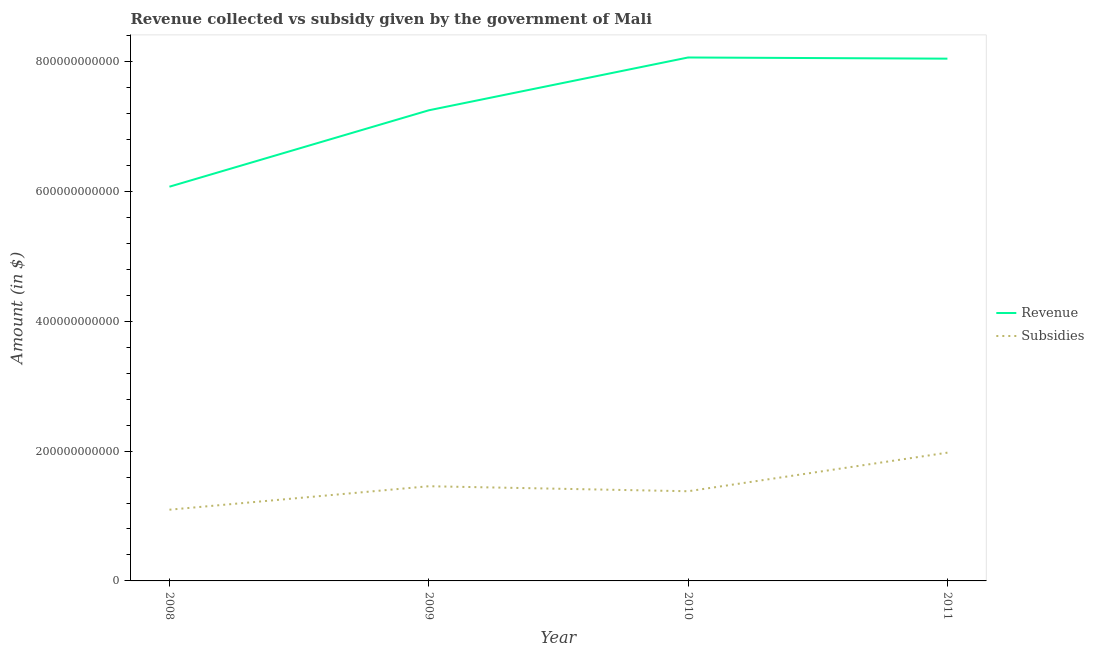How many different coloured lines are there?
Your answer should be compact. 2. Is the number of lines equal to the number of legend labels?
Make the answer very short. Yes. What is the amount of subsidies given in 2010?
Give a very brief answer. 1.38e+11. Across all years, what is the maximum amount of subsidies given?
Make the answer very short. 1.98e+11. Across all years, what is the minimum amount of subsidies given?
Provide a short and direct response. 1.10e+11. In which year was the amount of subsidies given maximum?
Your response must be concise. 2011. In which year was the amount of revenue collected minimum?
Make the answer very short. 2008. What is the total amount of revenue collected in the graph?
Offer a very short reply. 2.94e+12. What is the difference between the amount of subsidies given in 2008 and that in 2009?
Give a very brief answer. -3.62e+1. What is the difference between the amount of subsidies given in 2009 and the amount of revenue collected in 2008?
Ensure brevity in your answer.  -4.61e+11. What is the average amount of subsidies given per year?
Provide a succinct answer. 1.48e+11. In the year 2009, what is the difference between the amount of subsidies given and amount of revenue collected?
Keep it short and to the point. -5.79e+11. In how many years, is the amount of revenue collected greater than 240000000000 $?
Your answer should be very brief. 4. What is the ratio of the amount of subsidies given in 2008 to that in 2011?
Offer a terse response. 0.56. Is the amount of subsidies given in 2009 less than that in 2011?
Provide a short and direct response. Yes. What is the difference between the highest and the second highest amount of subsidies given?
Make the answer very short. 5.17e+1. What is the difference between the highest and the lowest amount of revenue collected?
Provide a succinct answer. 1.99e+11. In how many years, is the amount of revenue collected greater than the average amount of revenue collected taken over all years?
Offer a terse response. 2. Does the amount of subsidies given monotonically increase over the years?
Ensure brevity in your answer.  No. Is the amount of subsidies given strictly less than the amount of revenue collected over the years?
Your answer should be very brief. Yes. How many lines are there?
Make the answer very short. 2. How many years are there in the graph?
Your response must be concise. 4. What is the difference between two consecutive major ticks on the Y-axis?
Provide a short and direct response. 2.00e+11. How many legend labels are there?
Give a very brief answer. 2. What is the title of the graph?
Provide a short and direct response. Revenue collected vs subsidy given by the government of Mali. What is the label or title of the Y-axis?
Offer a very short reply. Amount (in $). What is the Amount (in $) in Revenue in 2008?
Provide a succinct answer. 6.07e+11. What is the Amount (in $) in Subsidies in 2008?
Provide a succinct answer. 1.10e+11. What is the Amount (in $) in Revenue in 2009?
Make the answer very short. 7.25e+11. What is the Amount (in $) of Subsidies in 2009?
Provide a short and direct response. 1.46e+11. What is the Amount (in $) of Revenue in 2010?
Offer a terse response. 8.06e+11. What is the Amount (in $) in Subsidies in 2010?
Offer a terse response. 1.38e+11. What is the Amount (in $) of Revenue in 2011?
Provide a succinct answer. 8.05e+11. What is the Amount (in $) of Subsidies in 2011?
Give a very brief answer. 1.98e+11. Across all years, what is the maximum Amount (in $) in Revenue?
Your answer should be compact. 8.06e+11. Across all years, what is the maximum Amount (in $) in Subsidies?
Your response must be concise. 1.98e+11. Across all years, what is the minimum Amount (in $) of Revenue?
Ensure brevity in your answer.  6.07e+11. Across all years, what is the minimum Amount (in $) in Subsidies?
Give a very brief answer. 1.10e+11. What is the total Amount (in $) in Revenue in the graph?
Give a very brief answer. 2.94e+12. What is the total Amount (in $) of Subsidies in the graph?
Offer a very short reply. 5.91e+11. What is the difference between the Amount (in $) in Revenue in 2008 and that in 2009?
Make the answer very short. -1.18e+11. What is the difference between the Amount (in $) in Subsidies in 2008 and that in 2009?
Your answer should be very brief. -3.62e+1. What is the difference between the Amount (in $) in Revenue in 2008 and that in 2010?
Make the answer very short. -1.99e+11. What is the difference between the Amount (in $) of Subsidies in 2008 and that in 2010?
Offer a terse response. -2.84e+1. What is the difference between the Amount (in $) in Revenue in 2008 and that in 2011?
Make the answer very short. -1.97e+11. What is the difference between the Amount (in $) of Subsidies in 2008 and that in 2011?
Your answer should be compact. -8.79e+1. What is the difference between the Amount (in $) in Revenue in 2009 and that in 2010?
Your response must be concise. -8.14e+1. What is the difference between the Amount (in $) in Subsidies in 2009 and that in 2010?
Provide a succinct answer. 7.72e+09. What is the difference between the Amount (in $) of Revenue in 2009 and that in 2011?
Offer a very short reply. -7.96e+1. What is the difference between the Amount (in $) of Subsidies in 2009 and that in 2011?
Make the answer very short. -5.17e+1. What is the difference between the Amount (in $) of Revenue in 2010 and that in 2011?
Offer a terse response. 1.80e+09. What is the difference between the Amount (in $) of Subsidies in 2010 and that in 2011?
Make the answer very short. -5.94e+1. What is the difference between the Amount (in $) in Revenue in 2008 and the Amount (in $) in Subsidies in 2009?
Give a very brief answer. 4.61e+11. What is the difference between the Amount (in $) in Revenue in 2008 and the Amount (in $) in Subsidies in 2010?
Your response must be concise. 4.69e+11. What is the difference between the Amount (in $) of Revenue in 2008 and the Amount (in $) of Subsidies in 2011?
Provide a succinct answer. 4.10e+11. What is the difference between the Amount (in $) in Revenue in 2009 and the Amount (in $) in Subsidies in 2010?
Offer a very short reply. 5.87e+11. What is the difference between the Amount (in $) of Revenue in 2009 and the Amount (in $) of Subsidies in 2011?
Your answer should be very brief. 5.27e+11. What is the difference between the Amount (in $) of Revenue in 2010 and the Amount (in $) of Subsidies in 2011?
Your answer should be compact. 6.09e+11. What is the average Amount (in $) of Revenue per year?
Your answer should be very brief. 7.36e+11. What is the average Amount (in $) in Subsidies per year?
Offer a very short reply. 1.48e+11. In the year 2008, what is the difference between the Amount (in $) in Revenue and Amount (in $) in Subsidies?
Provide a succinct answer. 4.98e+11. In the year 2009, what is the difference between the Amount (in $) in Revenue and Amount (in $) in Subsidies?
Give a very brief answer. 5.79e+11. In the year 2010, what is the difference between the Amount (in $) of Revenue and Amount (in $) of Subsidies?
Keep it short and to the point. 6.68e+11. In the year 2011, what is the difference between the Amount (in $) of Revenue and Amount (in $) of Subsidies?
Offer a very short reply. 6.07e+11. What is the ratio of the Amount (in $) of Revenue in 2008 to that in 2009?
Your response must be concise. 0.84. What is the ratio of the Amount (in $) in Subsidies in 2008 to that in 2009?
Provide a short and direct response. 0.75. What is the ratio of the Amount (in $) in Revenue in 2008 to that in 2010?
Your response must be concise. 0.75. What is the ratio of the Amount (in $) in Subsidies in 2008 to that in 2010?
Your answer should be compact. 0.79. What is the ratio of the Amount (in $) of Revenue in 2008 to that in 2011?
Keep it short and to the point. 0.75. What is the ratio of the Amount (in $) of Subsidies in 2008 to that in 2011?
Offer a very short reply. 0.56. What is the ratio of the Amount (in $) of Revenue in 2009 to that in 2010?
Offer a very short reply. 0.9. What is the ratio of the Amount (in $) of Subsidies in 2009 to that in 2010?
Provide a short and direct response. 1.06. What is the ratio of the Amount (in $) in Revenue in 2009 to that in 2011?
Offer a very short reply. 0.9. What is the ratio of the Amount (in $) of Subsidies in 2009 to that in 2011?
Keep it short and to the point. 0.74. What is the ratio of the Amount (in $) of Revenue in 2010 to that in 2011?
Offer a very short reply. 1. What is the ratio of the Amount (in $) of Subsidies in 2010 to that in 2011?
Your answer should be very brief. 0.7. What is the difference between the highest and the second highest Amount (in $) of Revenue?
Offer a very short reply. 1.80e+09. What is the difference between the highest and the second highest Amount (in $) in Subsidies?
Provide a short and direct response. 5.17e+1. What is the difference between the highest and the lowest Amount (in $) of Revenue?
Keep it short and to the point. 1.99e+11. What is the difference between the highest and the lowest Amount (in $) of Subsidies?
Your answer should be compact. 8.79e+1. 